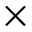Convert formula to latex. <formula><loc_0><loc_0><loc_500><loc_500>\times</formula> 